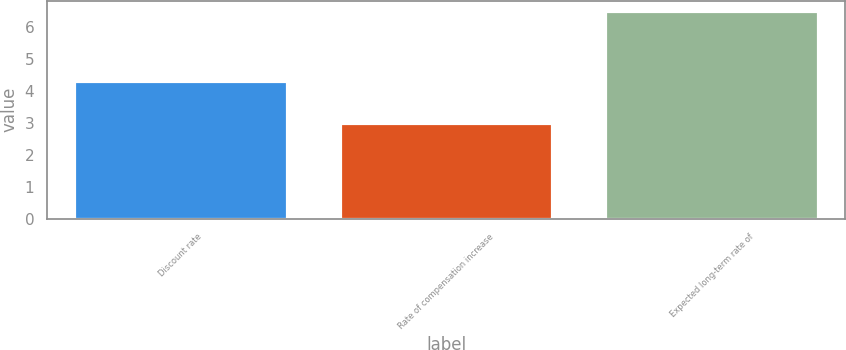Convert chart to OTSL. <chart><loc_0><loc_0><loc_500><loc_500><bar_chart><fcel>Discount rate<fcel>Rate of compensation increase<fcel>Expected long-term rate of<nl><fcel>4.3<fcel>3<fcel>6.5<nl></chart> 